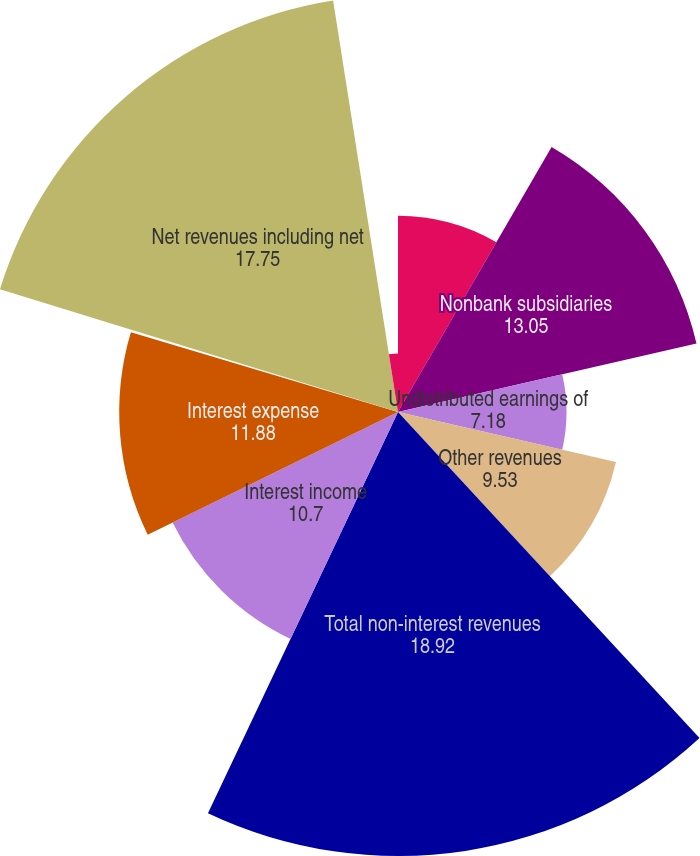<chart> <loc_0><loc_0><loc_500><loc_500><pie_chart><fcel>in millions<fcel>Nonbank subsidiaries<fcel>Undistributed earnings of<fcel>Other revenues<fcel>Total non-interest revenues<fcel>Interest income<fcel>Interest expense<fcel>Net interest income/(loss)<fcel>Net revenues including net<fcel>Compensation and benefits<nl><fcel>8.36%<fcel>13.05%<fcel>7.18%<fcel>9.53%<fcel>18.92%<fcel>10.7%<fcel>11.88%<fcel>0.14%<fcel>17.75%<fcel>2.49%<nl></chart> 